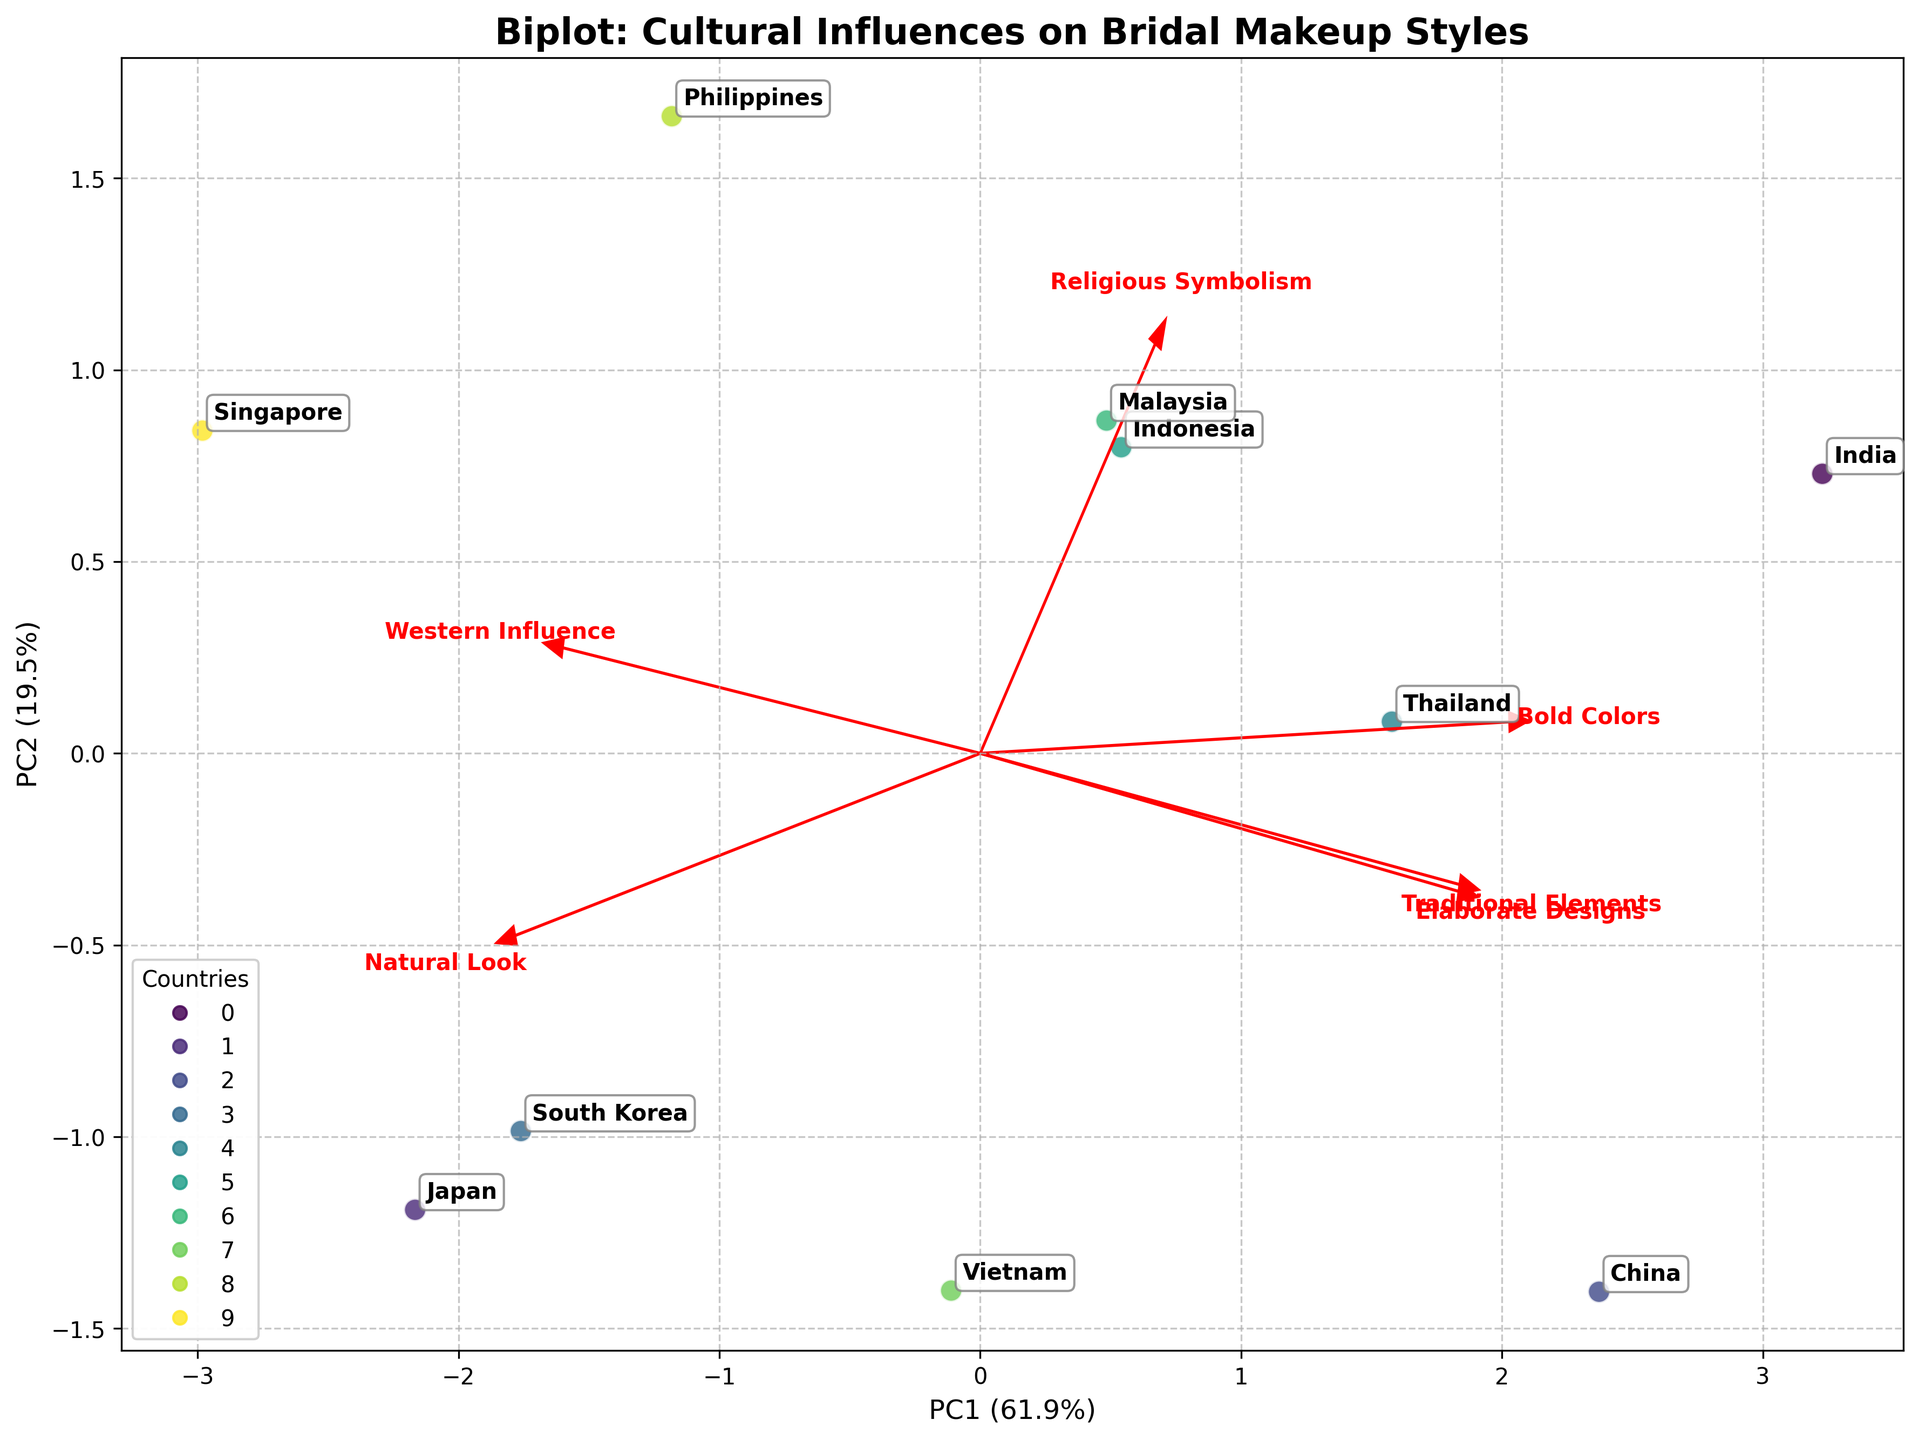Which country shows the highest traditional elements in bridal makeup? The plot shows points representing each country's bridal makeup characteristics. The point for India is closest to the arrow representing traditional elements.
Answer: India Which feature has the highest influence on the PC1 axis? By examining the length of the arrows along the PC1 axis, "Traditional Elements" has the largest projection.
Answer: Traditional Elements How do Japan and South Korea compare in terms of Western influence? Japan and South Korea both have projections in a similar direction along the Western influence vector; however, South Korea is placed farther along this axis.
Answer: South Korea shows greater Western influence How is religious symbolism represented in the Philippines compared to Malaysia? Both countries are relatively similar along the religious symbolism vector, but the Philippines is slightly more aligned with this axis.
Answer: Philippines shows more religious symbolism Which country has the most balance between traditional elements and natural look? The balance can be inferred where a country is reasonably well-placed along both vectors. Japan has notable projections on both traditional elements and natural look.
Answer: Japan What relation can be observed between elaborate designs and bold colors in the bridal makeup styles for China? China's data point is located prominently in the direction of both bold colors and elaborate designs, indicating a strong influence of both features.
Answer: Strong relation, both features are prominent Which feature shows the least variance across countries? To find this, we see which vector has the shortest arrow. This is the "Religious Symbolism" vector.
Answer: Religious Symbolism Are there any countries that strongly prefer a natural look? Japan has a strong projection along the natural look vector, placing it closest to this feature.
Answer: Japan Which cultural aspect is strongly present in Indonesia's bridal makeup compared to others? Based on Indonesia's data point, it has a high alignment with religious symbolism and traditional elements.
Answer: Religious Symbolism 